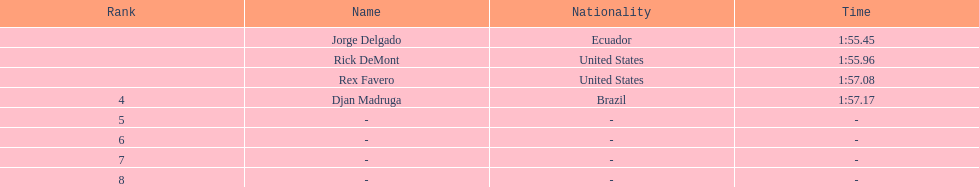What is the usual time span? 1:56.42. 